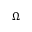<formula> <loc_0><loc_0><loc_500><loc_500>\Omega</formula> 